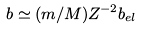Convert formula to latex. <formula><loc_0><loc_0><loc_500><loc_500>b \simeq ( m / M ) Z ^ { - 2 } b _ { e l }</formula> 